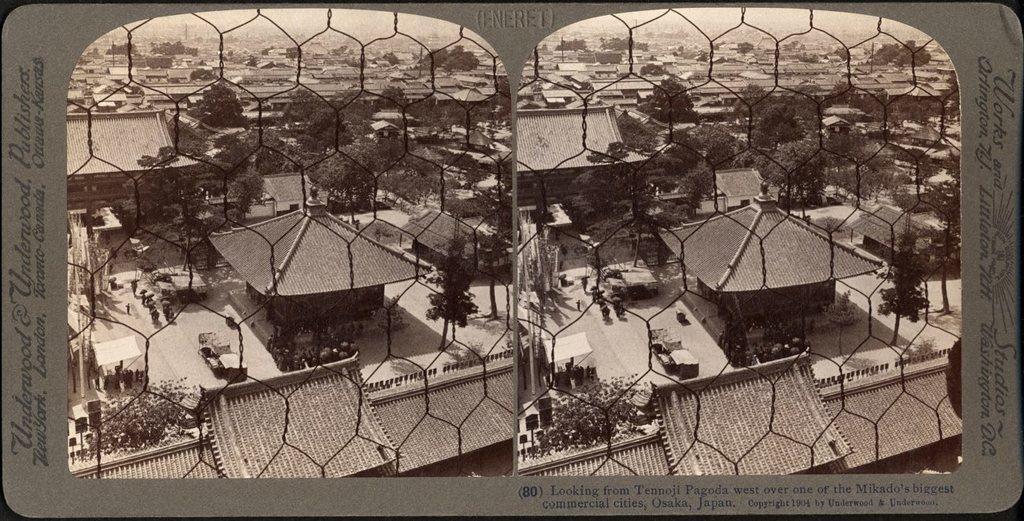Can you describe this image briefly? This is an edited image of a city where there are buildings, poles, boards, trees,sky. 